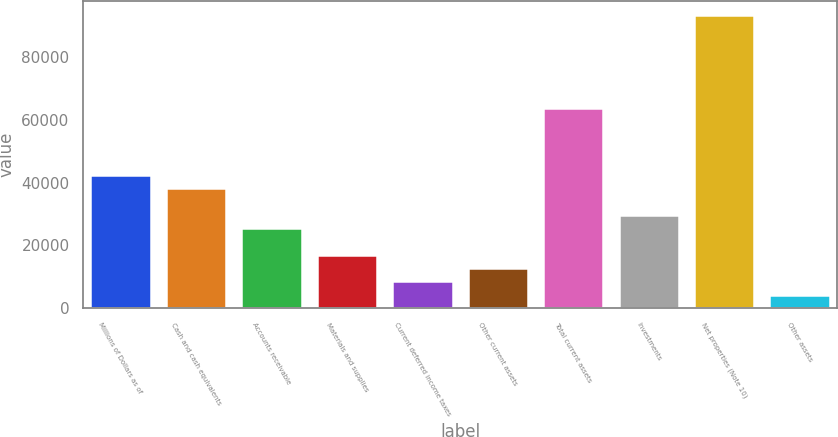Convert chart. <chart><loc_0><loc_0><loc_500><loc_500><bar_chart><fcel>Millions of Dollars as of<fcel>Cash and cash equivalents<fcel>Accounts receivable<fcel>Materials and supplies<fcel>Current deferred income taxes<fcel>Other current assets<fcel>Total current assets<fcel>Investments<fcel>Net properties (Note 10)<fcel>Other assets<nl><fcel>42410<fcel>38190.2<fcel>25530.8<fcel>17091.2<fcel>8651.6<fcel>12871.4<fcel>63509<fcel>29750.6<fcel>93047.6<fcel>4431.8<nl></chart> 